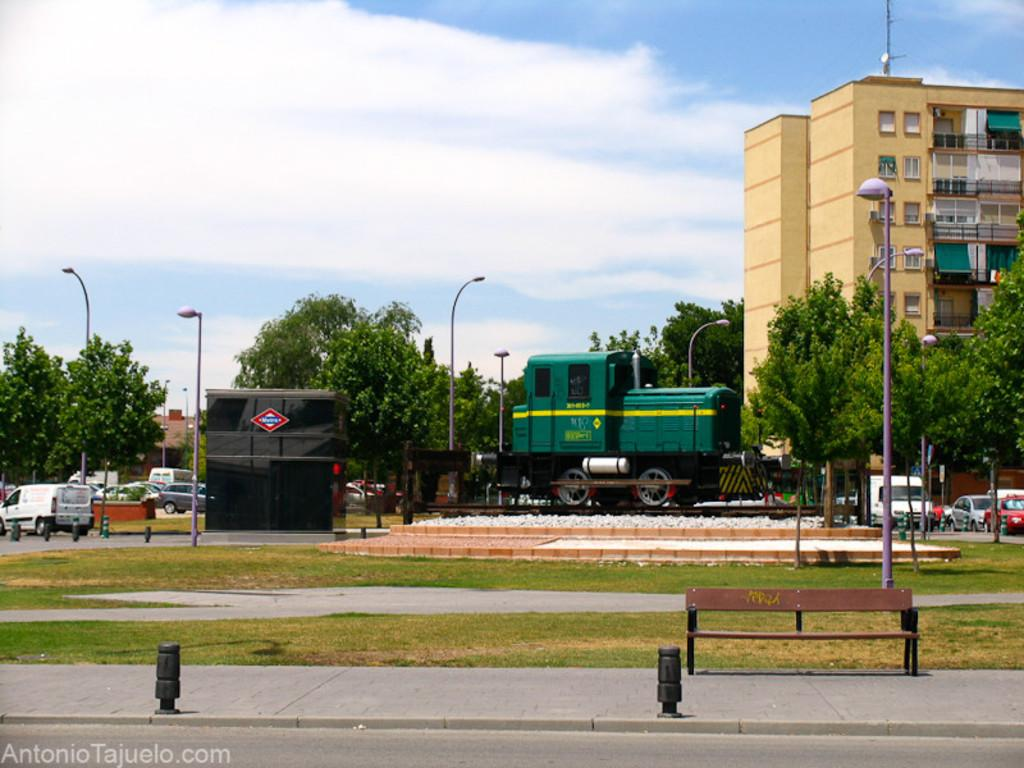What is the main mode of transportation in the image? There is a train on the railway tracks in the image. What other types of transportation can be seen in the image? There are vehicles parked on the road in the image. What natural elements are present in the area? There are trees in the area. What man-made structures are present in the area? There are buildings in the area. What type of nail is being used to fix the train in the image? There is no nail present in the image, nor is there any indication that the train needs to be fixed. 